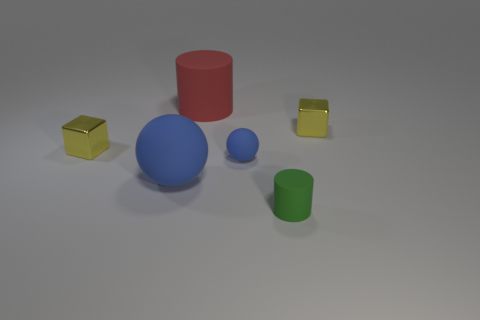What number of rubber things are large brown cubes or large cylinders?
Offer a terse response. 1. There is a rubber object that is both on the right side of the red object and behind the big blue sphere; how big is it?
Provide a succinct answer. Small. There is a tiny block that is right of the green matte cylinder; are there any big objects that are behind it?
Ensure brevity in your answer.  Yes. What number of small matte objects are on the left side of the tiny green matte thing?
Your answer should be very brief. 1. What is the color of the other object that is the same shape as the large blue object?
Offer a very short reply. Blue. Are the small object to the left of the red rubber thing and the ball on the right side of the large red cylinder made of the same material?
Keep it short and to the point. No. Does the big rubber ball have the same color as the small matte ball in front of the red rubber cylinder?
Provide a succinct answer. Yes. There is a small thing that is both to the left of the tiny green rubber cylinder and right of the large sphere; what shape is it?
Provide a succinct answer. Sphere. How many cylinders are there?
Your answer should be very brief. 2. There is another blue thing that is the same shape as the big blue thing; what size is it?
Ensure brevity in your answer.  Small. 